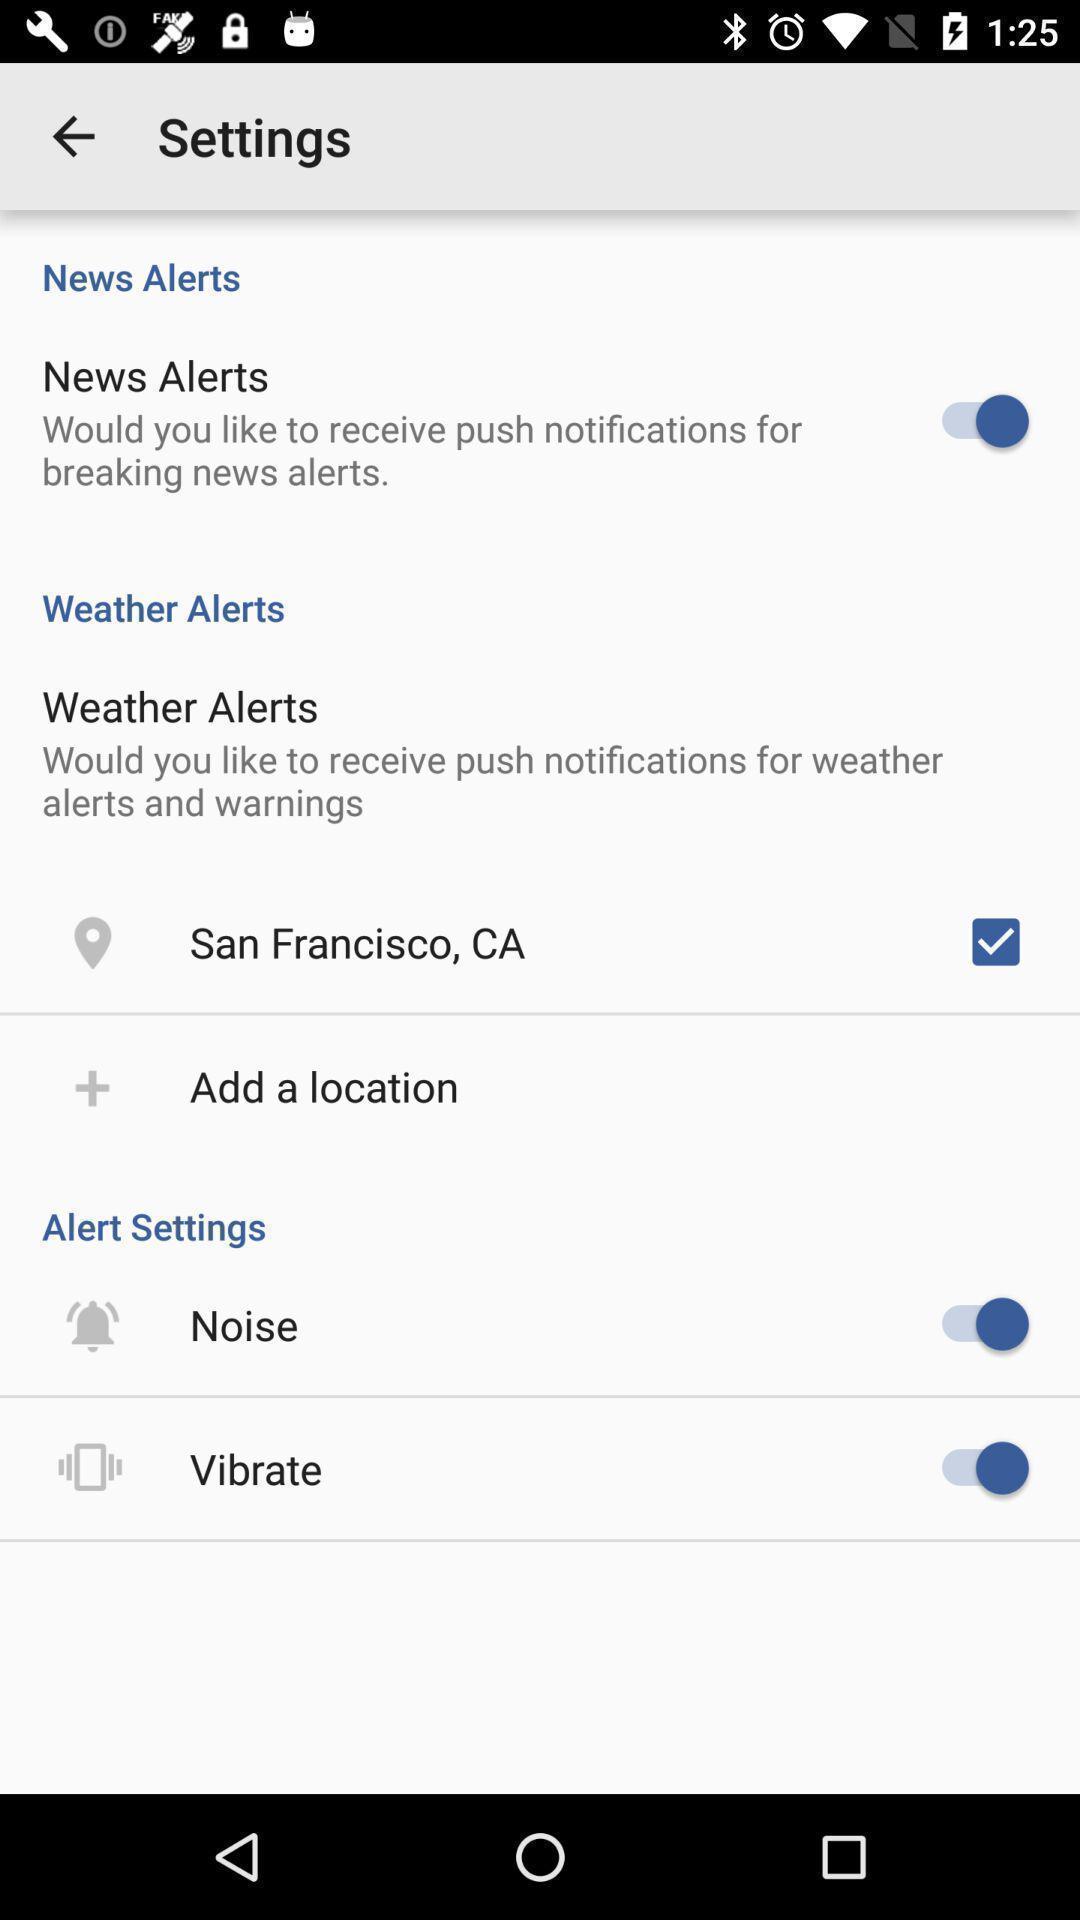What details can you identify in this image? Settings page showing various options. 